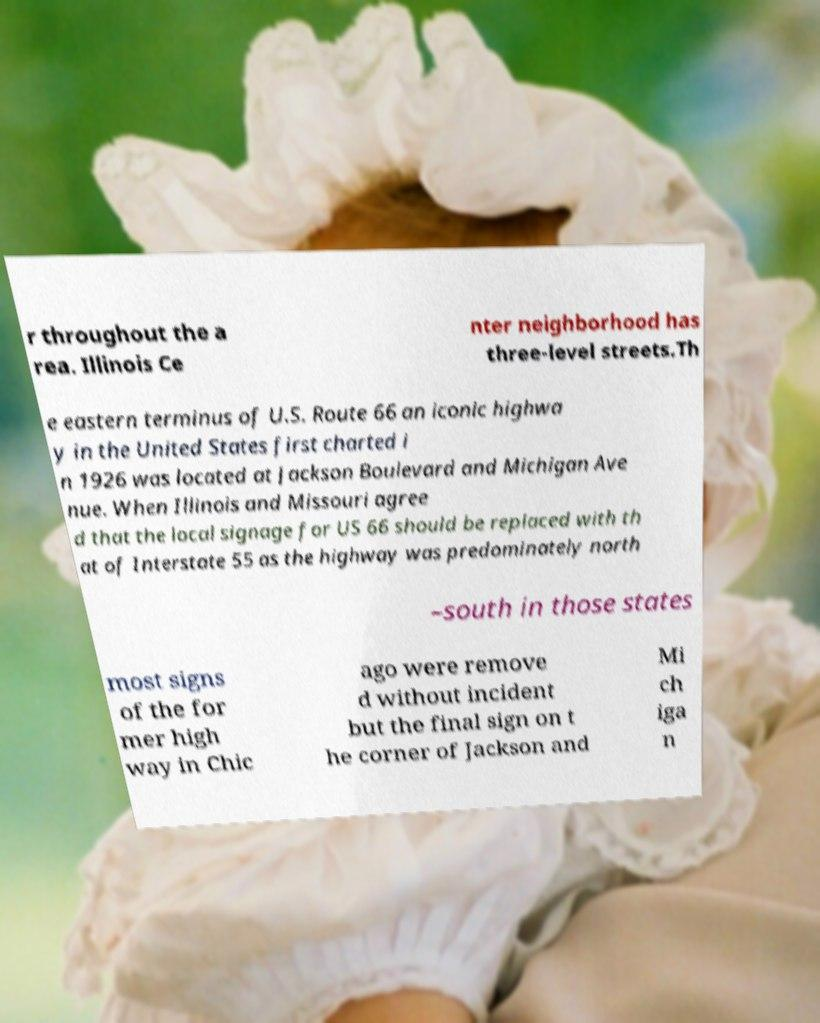For documentation purposes, I need the text within this image transcribed. Could you provide that? r throughout the a rea. Illinois Ce nter neighborhood has three-level streets.Th e eastern terminus of U.S. Route 66 an iconic highwa y in the United States first charted i n 1926 was located at Jackson Boulevard and Michigan Ave nue. When Illinois and Missouri agree d that the local signage for US 66 should be replaced with th at of Interstate 55 as the highway was predominately north –south in those states most signs of the for mer high way in Chic ago were remove d without incident but the final sign on t he corner of Jackson and Mi ch iga n 